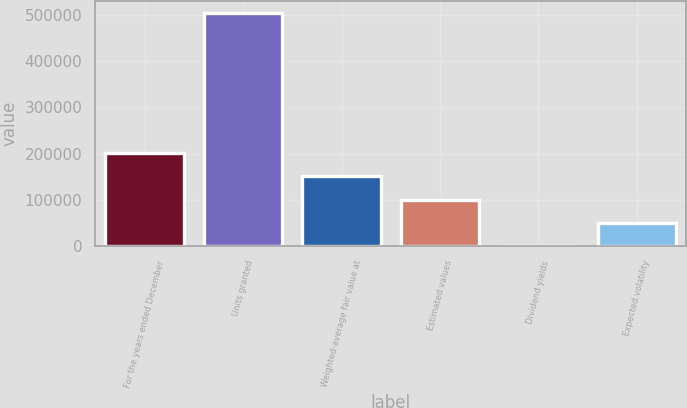Convert chart. <chart><loc_0><loc_0><loc_500><loc_500><bar_chart><fcel>For the years ended December<fcel>Units granted<fcel>Weighted-average fair value at<fcel>Estimated values<fcel>Dividend yields<fcel>Expected volatility<nl><fcel>201506<fcel>503761<fcel>151130<fcel>100754<fcel>2.5<fcel>50378.3<nl></chart> 